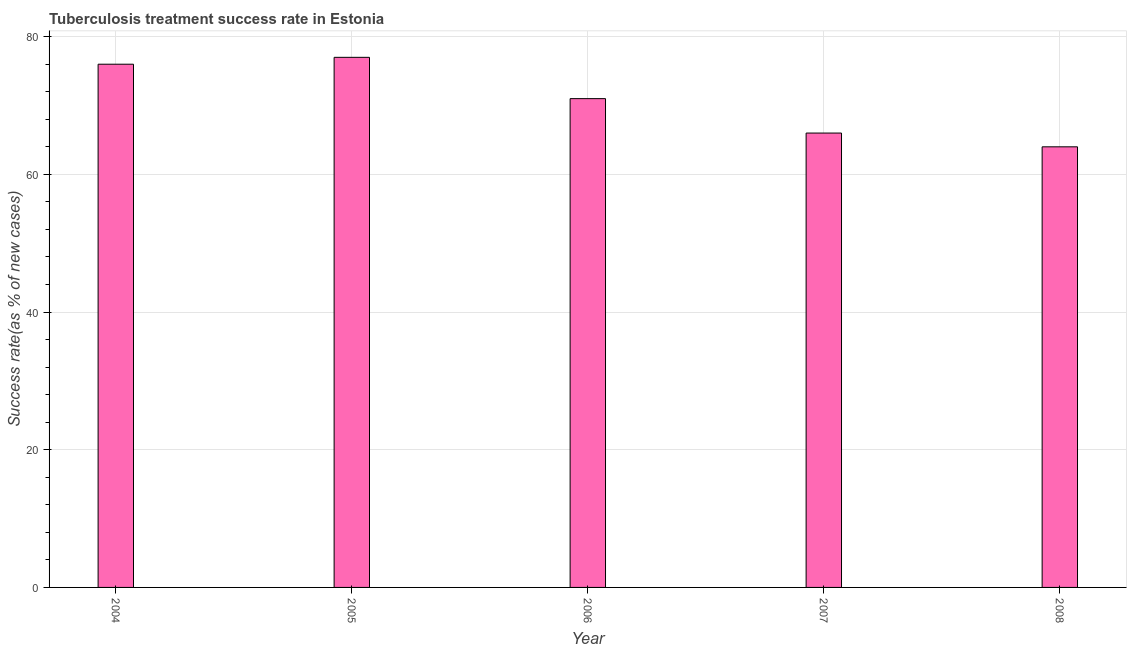What is the title of the graph?
Make the answer very short. Tuberculosis treatment success rate in Estonia. What is the label or title of the Y-axis?
Provide a succinct answer. Success rate(as % of new cases). Across all years, what is the minimum tuberculosis treatment success rate?
Provide a succinct answer. 64. In which year was the tuberculosis treatment success rate minimum?
Provide a short and direct response. 2008. What is the sum of the tuberculosis treatment success rate?
Provide a succinct answer. 354. What is the difference between the tuberculosis treatment success rate in 2004 and 2006?
Offer a terse response. 5. What is the median tuberculosis treatment success rate?
Your answer should be very brief. 71. Do a majority of the years between 2006 and 2004 (inclusive) have tuberculosis treatment success rate greater than 52 %?
Make the answer very short. Yes. What is the ratio of the tuberculosis treatment success rate in 2006 to that in 2007?
Give a very brief answer. 1.08. Is the difference between the tuberculosis treatment success rate in 2005 and 2006 greater than the difference between any two years?
Keep it short and to the point. No. What is the difference between the highest and the second highest tuberculosis treatment success rate?
Provide a succinct answer. 1. In how many years, is the tuberculosis treatment success rate greater than the average tuberculosis treatment success rate taken over all years?
Ensure brevity in your answer.  3. Are the values on the major ticks of Y-axis written in scientific E-notation?
Offer a very short reply. No. What is the Success rate(as % of new cases) in 2004?
Your answer should be compact. 76. What is the Success rate(as % of new cases) in 2008?
Your response must be concise. 64. What is the difference between the Success rate(as % of new cases) in 2004 and 2008?
Your answer should be very brief. 12. What is the difference between the Success rate(as % of new cases) in 2005 and 2006?
Ensure brevity in your answer.  6. What is the difference between the Success rate(as % of new cases) in 2005 and 2007?
Keep it short and to the point. 11. What is the difference between the Success rate(as % of new cases) in 2005 and 2008?
Give a very brief answer. 13. What is the difference between the Success rate(as % of new cases) in 2006 and 2007?
Give a very brief answer. 5. What is the ratio of the Success rate(as % of new cases) in 2004 to that in 2006?
Ensure brevity in your answer.  1.07. What is the ratio of the Success rate(as % of new cases) in 2004 to that in 2007?
Provide a succinct answer. 1.15. What is the ratio of the Success rate(as % of new cases) in 2004 to that in 2008?
Ensure brevity in your answer.  1.19. What is the ratio of the Success rate(as % of new cases) in 2005 to that in 2006?
Your answer should be very brief. 1.08. What is the ratio of the Success rate(as % of new cases) in 2005 to that in 2007?
Keep it short and to the point. 1.17. What is the ratio of the Success rate(as % of new cases) in 2005 to that in 2008?
Your answer should be compact. 1.2. What is the ratio of the Success rate(as % of new cases) in 2006 to that in 2007?
Make the answer very short. 1.08. What is the ratio of the Success rate(as % of new cases) in 2006 to that in 2008?
Give a very brief answer. 1.11. What is the ratio of the Success rate(as % of new cases) in 2007 to that in 2008?
Offer a very short reply. 1.03. 